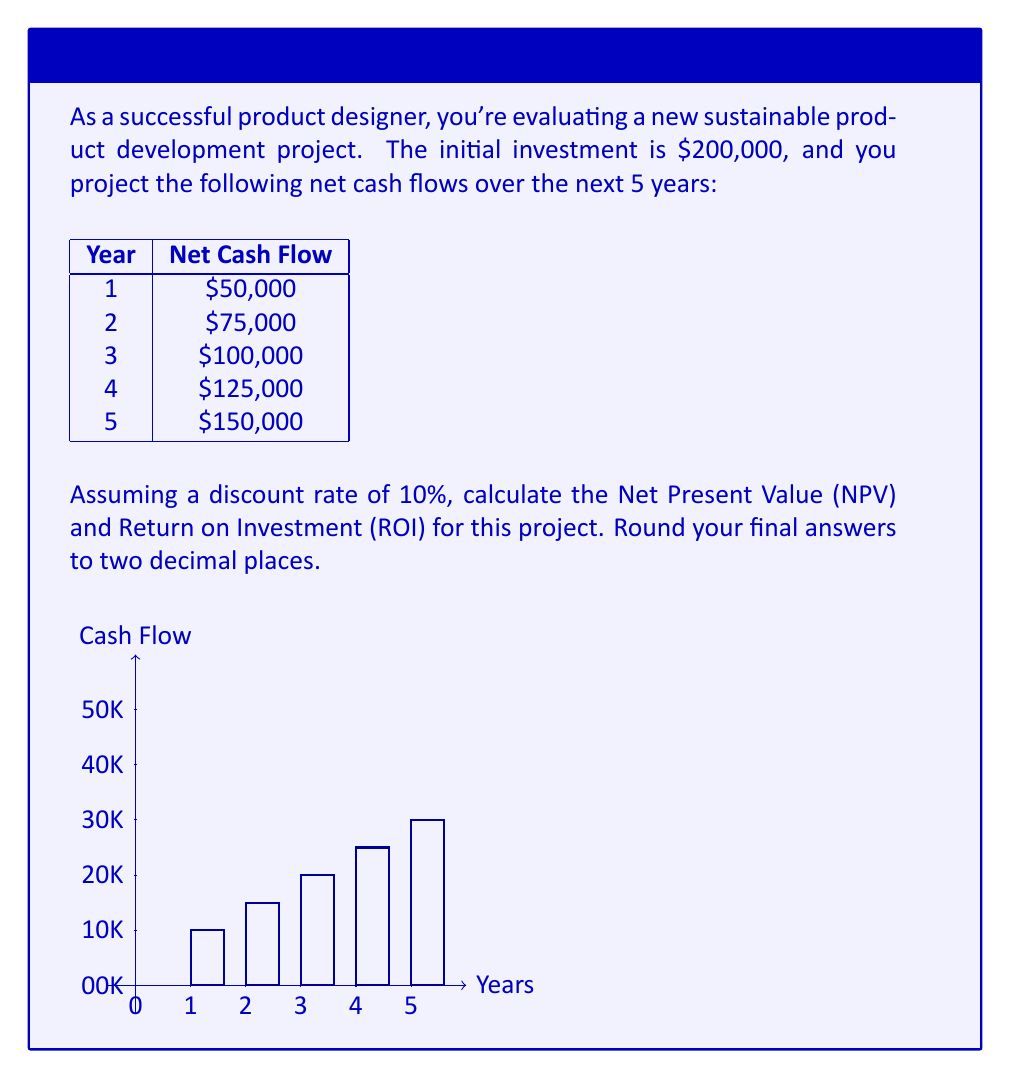Can you solve this math problem? Let's approach this step-by-step:

1) First, we need to calculate the Net Present Value (NPV). The formula for NPV is:

   $$NPV = -C_0 + \sum_{t=1}^{n} \frac{C_t}{(1+r)^t}$$

   Where $C_0$ is the initial investment, $C_t$ is the cash flow at time t, r is the discount rate, and n is the number of periods.

2) Let's calculate the present value of each cash flow:

   Year 1: $\frac{50,000}{(1+0.1)^1} = 45,454.55$
   Year 2: $\frac{75,000}{(1+0.1)^2} = 61,983.47$
   Year 3: $\frac{100,000}{(1+0.1)^3} = 75,131.48$
   Year 4: $\frac{125,000}{(1+0.1)^4} = 85,376.68$
   Year 5: $\frac{150,000}{(1+0.1)^5} = 93,138.52$

3) Sum these present values:
   
   $45,454.55 + 61,983.47 + 75,131.48 + 85,376.68 + 93,138.52 = 361,084.70$

4) Subtract the initial investment to get NPV:

   $NPV = 361,084.70 - 200,000 = 161,084.70$

5) Now, let's calculate the ROI. The formula for ROI is:

   $$ROI = \frac{\text{Gain from Investment} - \text{Cost of Investment}}{\text{Cost of Investment}} \times 100\%$$

6) In this case, the gain from investment is the NPV plus the initial investment:

   $\text{Gain from Investment} = 161,084.70 + 200,000 = 361,084.70$

7) Plugging into the ROI formula:

   $$ROI = \frac{361,084.70 - 200,000}{200,000} \times 100\% = 80.54\%$$
Answer: NPV = $161,084.70, ROI = 80.54% 